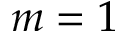<formula> <loc_0><loc_0><loc_500><loc_500>m = 1</formula> 